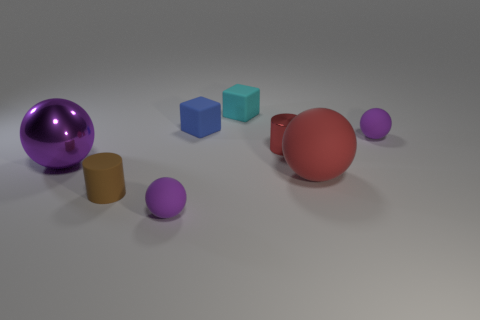Are there fewer large shiny spheres that are right of the big matte object than brown cylinders?
Keep it short and to the point. Yes. How many spheres have the same color as the small metal cylinder?
Provide a succinct answer. 1. What material is the purple thing that is on the left side of the blue matte block and to the right of the purple metallic thing?
Provide a succinct answer. Rubber. Does the tiny sphere that is in front of the tiny metallic cylinder have the same color as the matte ball that is behind the big red rubber object?
Offer a terse response. Yes. How many cyan objects are blocks or tiny things?
Keep it short and to the point. 1. Are there fewer rubber cubes on the right side of the tiny rubber cylinder than small brown matte objects that are left of the large purple shiny object?
Provide a short and direct response. No. Are there any cubes that have the same size as the red ball?
Keep it short and to the point. No. Is the size of the rubber sphere that is left of the cyan rubber object the same as the tiny brown cylinder?
Ensure brevity in your answer.  Yes. Are there more small objects than brown matte cylinders?
Your answer should be compact. Yes. Are there any tiny blue rubber things that have the same shape as the brown rubber thing?
Your answer should be very brief. No. 